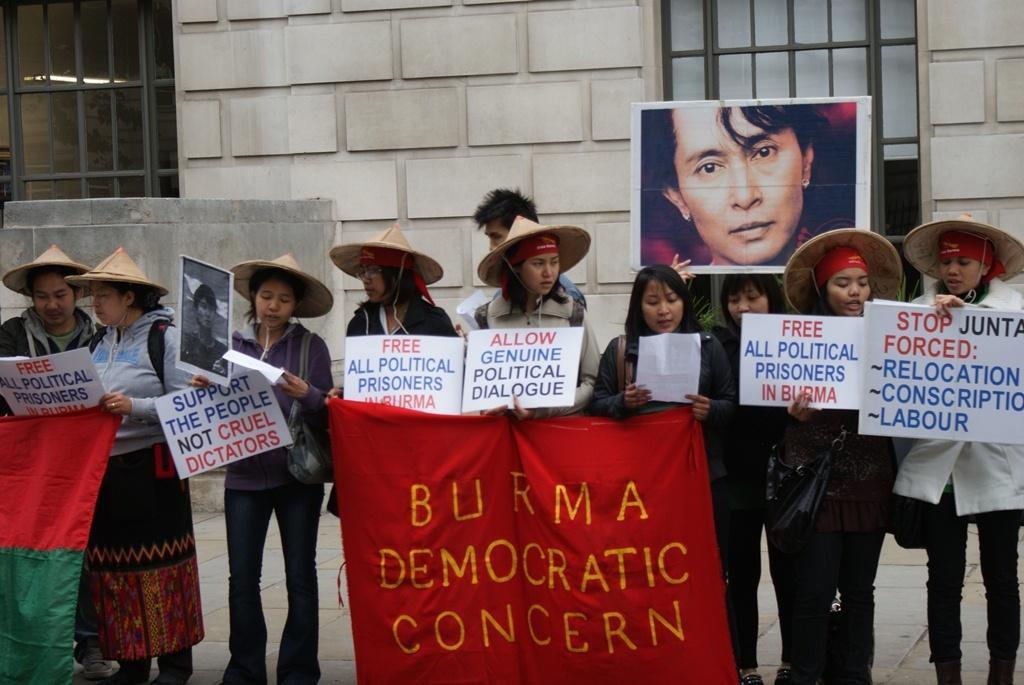How would you summarize this image in a sentence or two? In the image there are a group of people standing in a row, all of them are holding some posters in their hand and there is also a banner, is written as "Burma democratic concern" on the banner. One of the woman is holding the image of a person, behind the people there is a wall and there are two windows on the either side of the wall. 